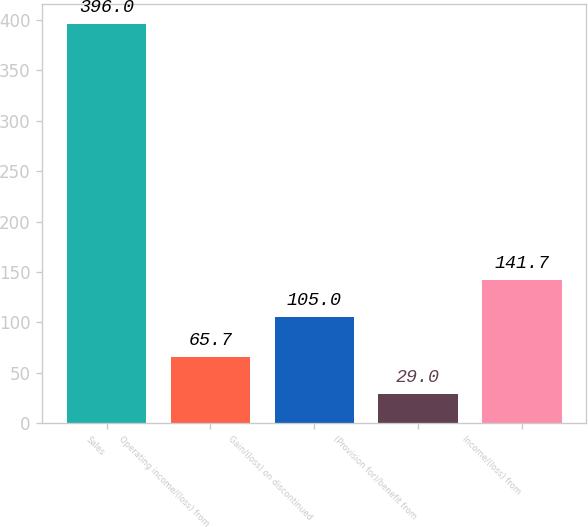<chart> <loc_0><loc_0><loc_500><loc_500><bar_chart><fcel>Sales<fcel>Operating income/(loss) from<fcel>Gain/(loss) on discontinued<fcel>(Provision for)/benefit from<fcel>Income/(loss) from<nl><fcel>396<fcel>65.7<fcel>105<fcel>29<fcel>141.7<nl></chart> 